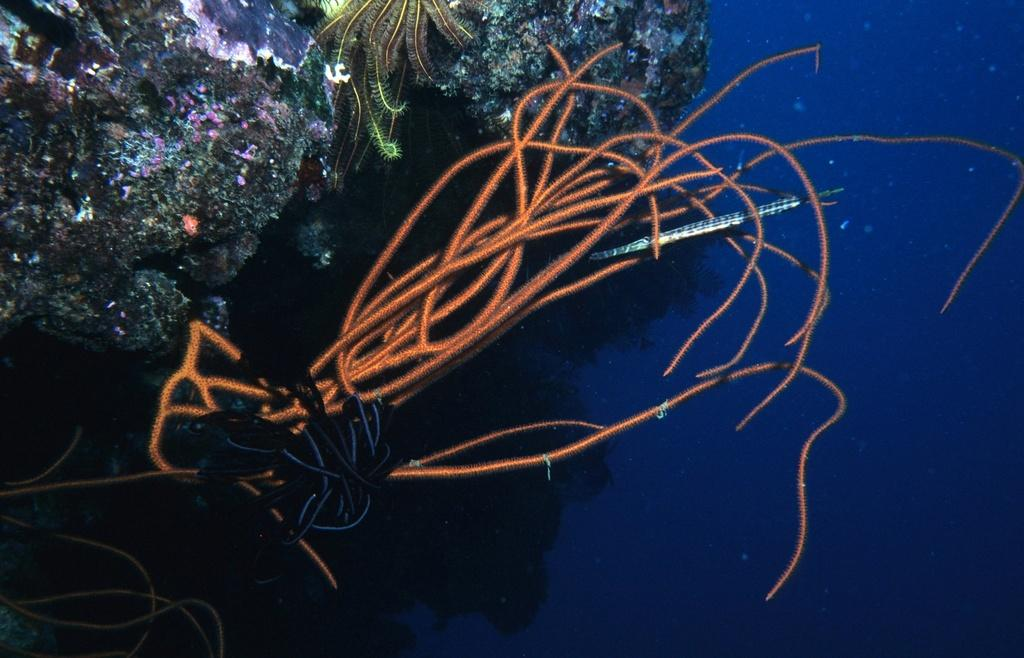Where was the image taken? The image was clicked inside the water. What can be seen to the left in the image? There are marine plants to the left in the image. What type of worm can be seen crawling on the air in the image? There is no worm or air present in the image, as it was taken underwater. 